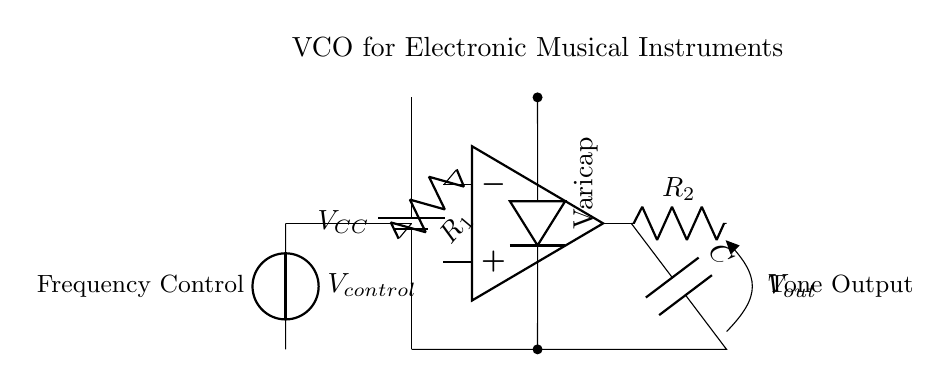What type of circuit is this? The circuit is a voltage-controlled oscillator, as indicated by the configuration and the inclusion of a control voltage that adjusts the frequency output.
Answer: Voltage-controlled oscillator What does VCC represent in the circuit? VCC represents the supply voltage for the circuit, which is the source of power for the oscillator's operation.
Answer: Power supply What component is responsible for adjusting the frequency in this circuit? The varicap diode, which is controlled by a voltage, varies capacitance and thereby modulates frequency output.
Answer: Varicap diode What is the function of resistor R1 in this circuit? Resistor R1 is connected to the inverting input of the operational amplifier, affecting the feedback and stabilizing the oscillator.
Answer: Feedback stabilization How does the control voltage influence the output tone? The control voltage alters the capacitance of the varicap diode, which in turn adjusts the frequency of the oscillation produced, thus varying the tone.
Answer: Modulates frequency What does the output voltage represent in this circuit? The output voltage Vout is the generated tone signal that is produced by the oscillator for use in electronic musical instruments.
Answer: Generated tone signal How is the capacitor connected in this oscillator circuit? The capacitor C is connected in feedback from the output of the op-amp to ground, allowing it to filter and stabilize the oscillation.
Answer: In feedback to ground 